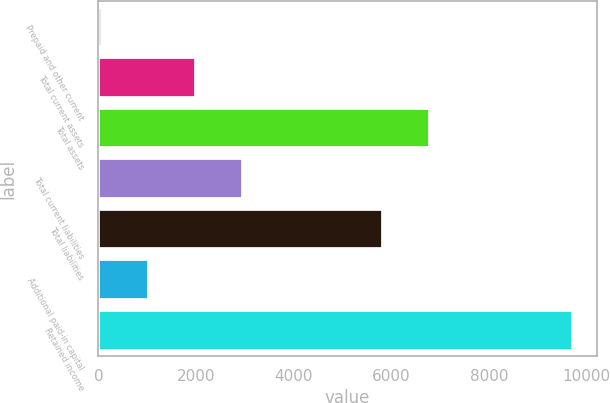Convert chart. <chart><loc_0><loc_0><loc_500><loc_500><bar_chart><fcel>Prepaid and other current<fcel>Total current assets<fcel>Total assets<fcel>Total current liabilities<fcel>Total liabilities<fcel>Additional paid-in capital<fcel>Retained income<nl><fcel>77<fcel>2005.8<fcel>6796<fcel>2970.2<fcel>5830<fcel>1041.4<fcel>9721<nl></chart> 